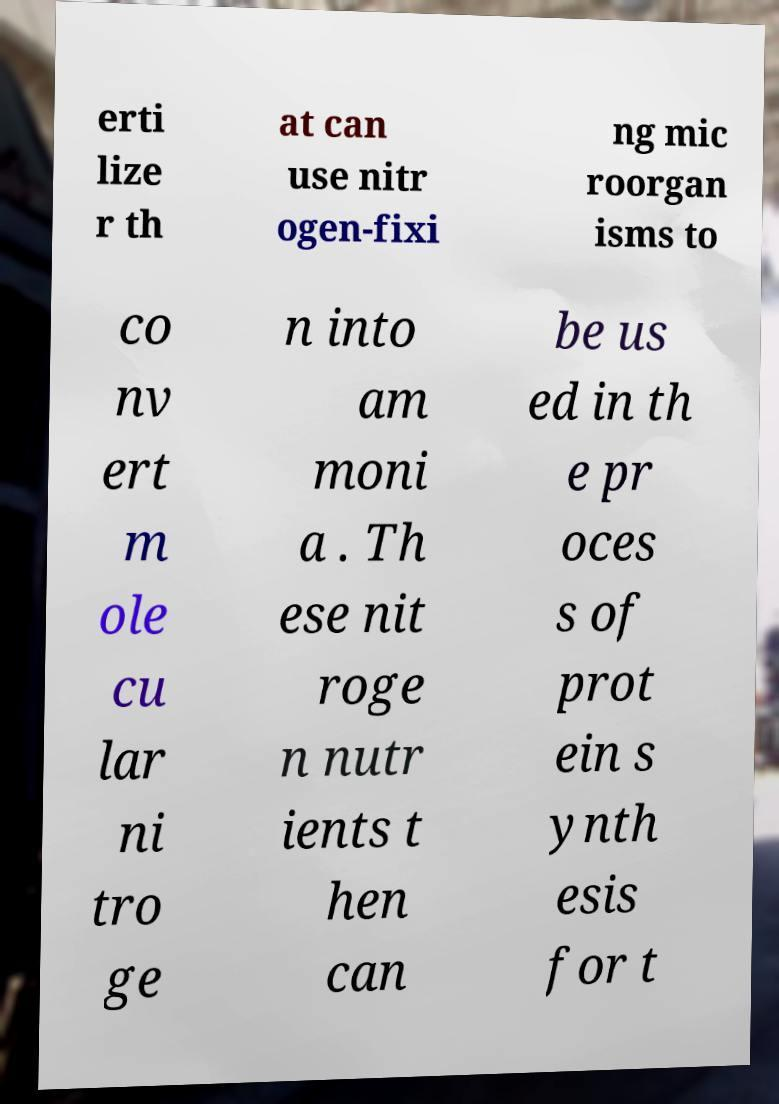Can you accurately transcribe the text from the provided image for me? erti lize r th at can use nitr ogen-fixi ng mic roorgan isms to co nv ert m ole cu lar ni tro ge n into am moni a . Th ese nit roge n nutr ients t hen can be us ed in th e pr oces s of prot ein s ynth esis for t 